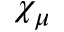Convert formula to latex. <formula><loc_0><loc_0><loc_500><loc_500>\chi _ { \mu }</formula> 